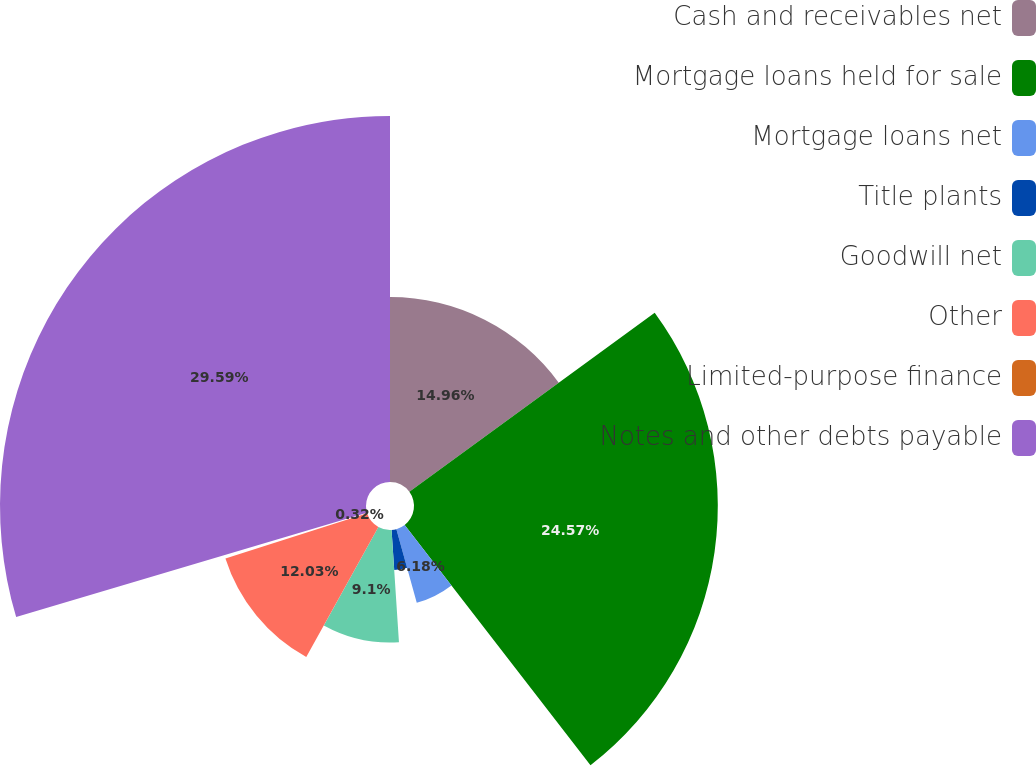Convert chart. <chart><loc_0><loc_0><loc_500><loc_500><pie_chart><fcel>Cash and receivables net<fcel>Mortgage loans held for sale<fcel>Mortgage loans net<fcel>Title plants<fcel>Goodwill net<fcel>Other<fcel>Limited-purpose finance<fcel>Notes and other debts payable<nl><fcel>14.96%<fcel>24.57%<fcel>6.18%<fcel>3.25%<fcel>9.1%<fcel>12.03%<fcel>0.32%<fcel>29.6%<nl></chart> 